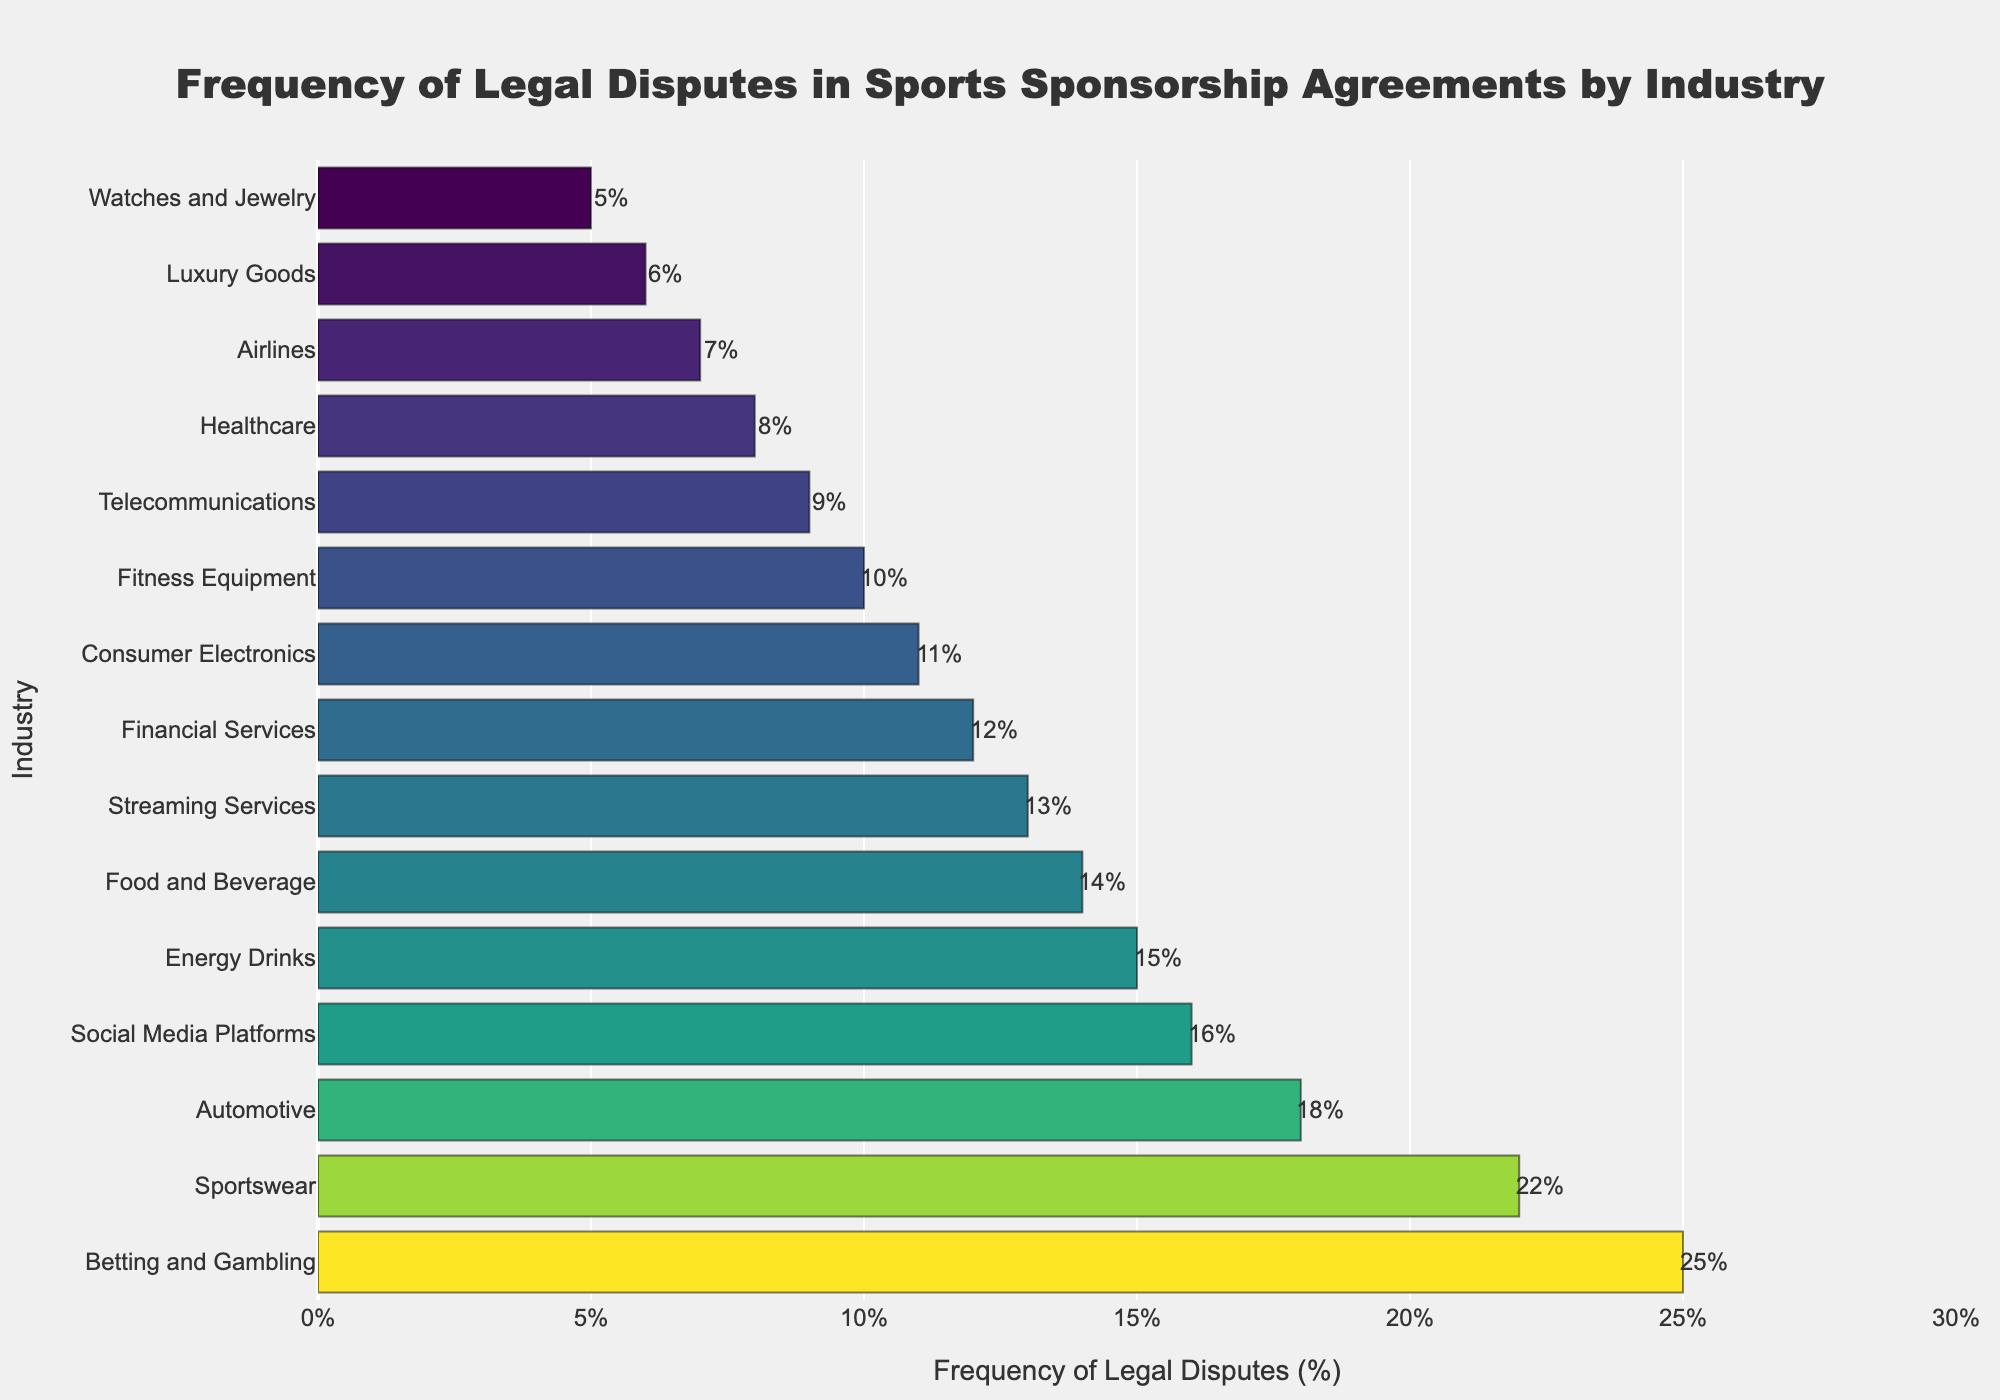Which industry has the highest frequency of legal disputes? The highest bar in the chart represents the industry with the highest frequency of legal disputes. In this case, the Betting and Gambling industry is at the top with 25%.
Answer: Betting and Gambling Which industry has fewer legal disputes, Healthcare or Airlines? Comparing the bars for Healthcare and Airlines, Healthcare has an 8% frequency of legal disputes while Airlines has 7%.
Answer: Airlines What is the total frequency of legal disputes for the top three industries? The top three industries are Betting and Gambling (25%), Sportswear (22%), and Automotive (18%). Adding these percentages: 25 + 22 + 18 = 65%.
Answer: 65% How much greater is the frequency of legal disputes in the Sportswear industry compared to the Financial Services industry? The frequency for Sportswear is 22% and for Financial Services, it is 12%. The difference is 22 - 12 = 10%.
Answer: 10% Identify the industry with the lowest frequency of legal disputes. The shortest bar represents the industry with the lowest frequency. Here, the Watches and Jewelry industry has the lowest frequency at 5%.
Answer: Watches and Jewelry What is the median frequency of legal disputes across all industries presented? To find the median, list the frequencies in order: 5, 6, 7, 8, 9, 10, 11, 12, 13, 14, 15, 16, 18, 22, 25. The median is the middle number, so the 8th value since there are 15 numbers. The median is 12%.
Answer: 12% How does the frequency of legal disputes in Streaming Services compare to that in Social Media Platforms? The frequency for Streaming Services is 13%, while for Social Media Platforms, it is 16%.
Answer: Social Media Platforms has a higher frequency Which two industries have exactly one percentage point difference in their frequencies? Comparing the frequencies, Healthcare (8%) and Telecommunications (9%) differ by one percentage point. Similarly, Consumer Electronics (11%) and Financial Services (12%) differ by one percentage point as well.
Answer: Healthcare and Telecommunications, Consumer Electronics and Financial Services What is the average frequency of legal disputes for industries related to technology (Telecommunications, Consumer Electronics, Social Media Platforms)? The frequencies are Telecommunications (9%), Consumer Electronics (11%), and Social Media Platforms (16%). The average is (9 + 11 + 16) / 3 = 12%.
Answer: 12% 